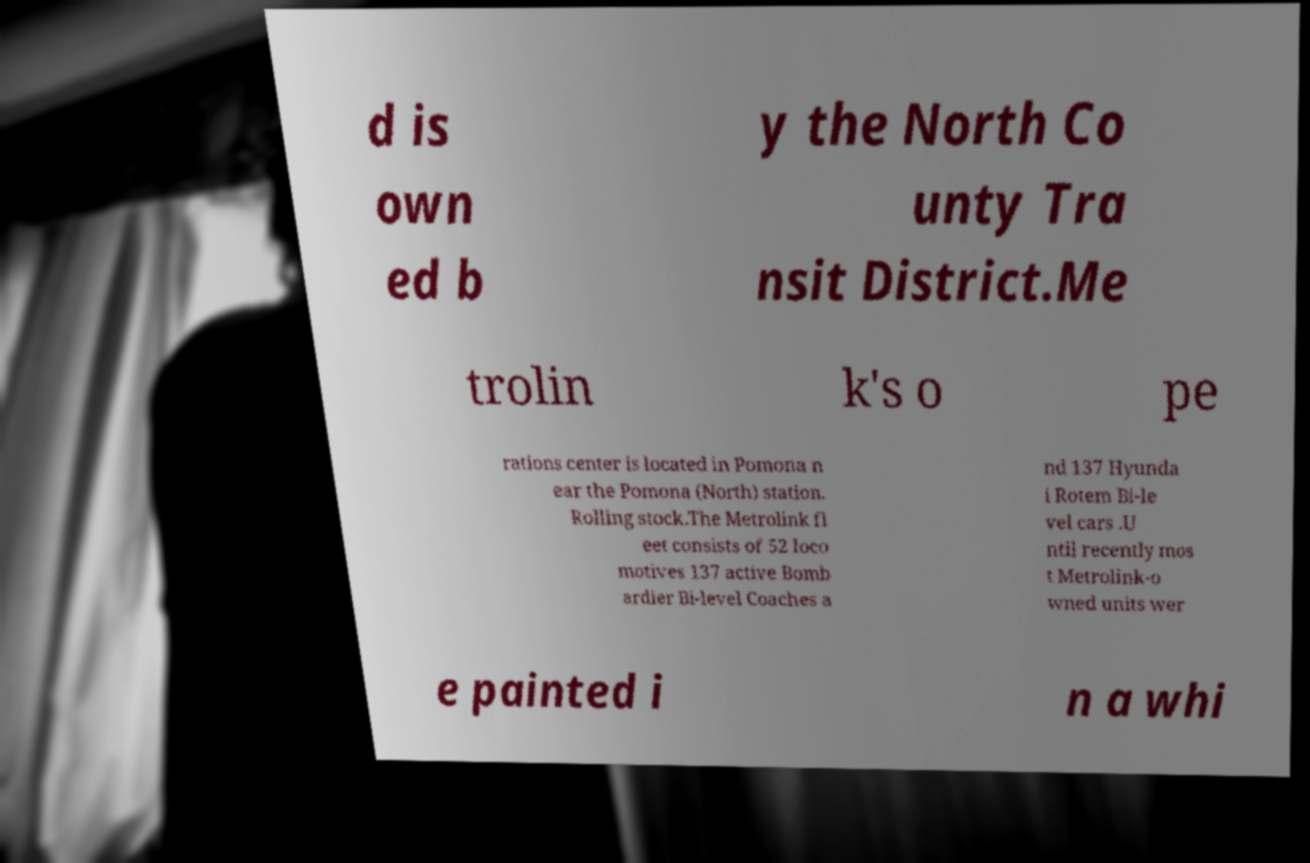Can you read and provide the text displayed in the image?This photo seems to have some interesting text. Can you extract and type it out for me? d is own ed b y the North Co unty Tra nsit District.Me trolin k's o pe rations center is located in Pomona n ear the Pomona (North) station. Rolling stock.The Metrolink fl eet consists of 52 loco motives 137 active Bomb ardier Bi-level Coaches a nd 137 Hyunda i Rotem Bi-le vel cars .U ntil recently mos t Metrolink-o wned units wer e painted i n a whi 